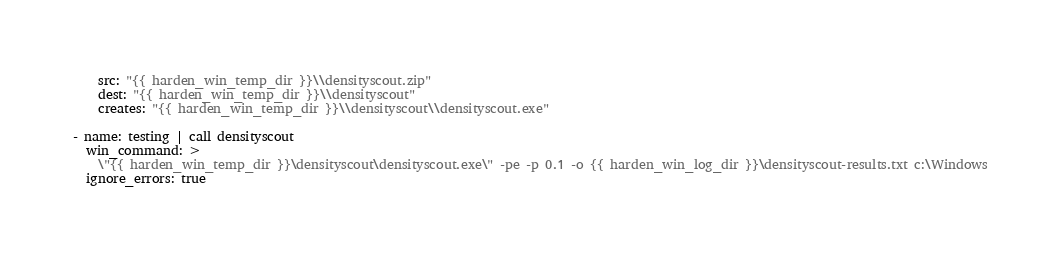<code> <loc_0><loc_0><loc_500><loc_500><_YAML_>    src: "{{ harden_win_temp_dir }}\\densityscout.zip"
    dest: "{{ harden_win_temp_dir }}\\densityscout"
    creates: "{{ harden_win_temp_dir }}\\densityscout\\densityscout.exe"

- name: testing | call densityscout
  win_command: >
    \"{{ harden_win_temp_dir }}\densityscout\densityscout.exe\" -pe -p 0.1 -o {{ harden_win_log_dir }}\densityscout-results.txt c:\Windows
  ignore_errors: true
</code> 